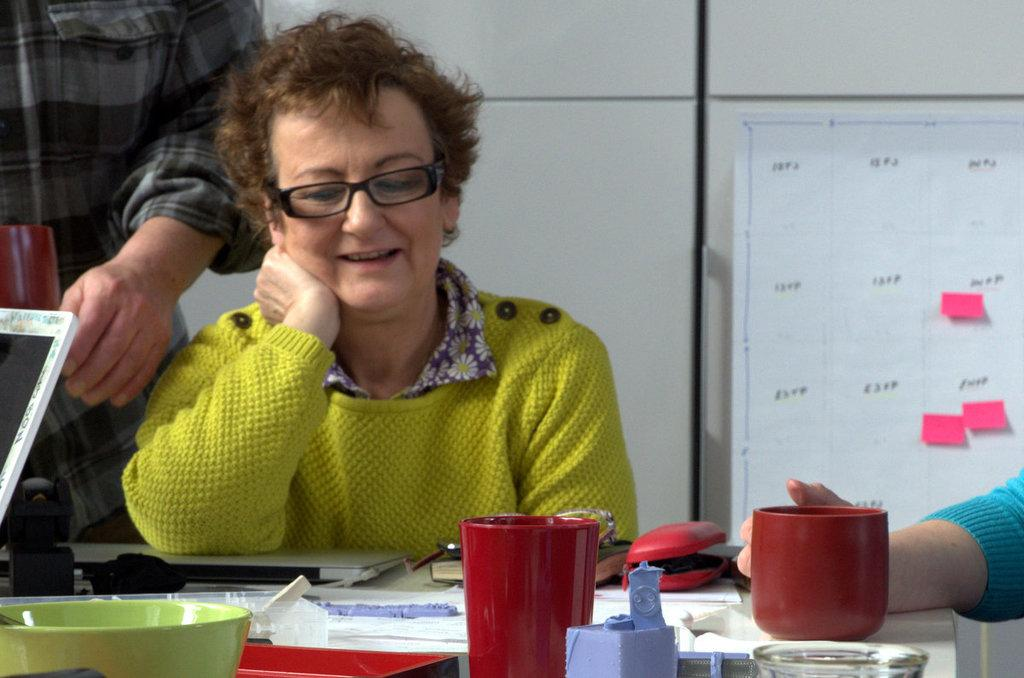What are the people in the image doing? The people in the image are sitting around the table. What electronic devices are on the table? There are laptops on the table. What type of tableware is present on the table? There are glasses and bowls on the table. What other objects can be seen on the table? There are other objects on the table, but their specific details are not mentioned in the facts. What is attached to the wall in the image? There is a chart attached to the wall. What type of muscle is being exercised by the people sitting around the table? There is no indication of any physical activity or muscle exercise in the image. Is there a tent visible in the image? No, there is no tent present in the image. 